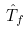Convert formula to latex. <formula><loc_0><loc_0><loc_500><loc_500>\hat { T } _ { f }</formula> 